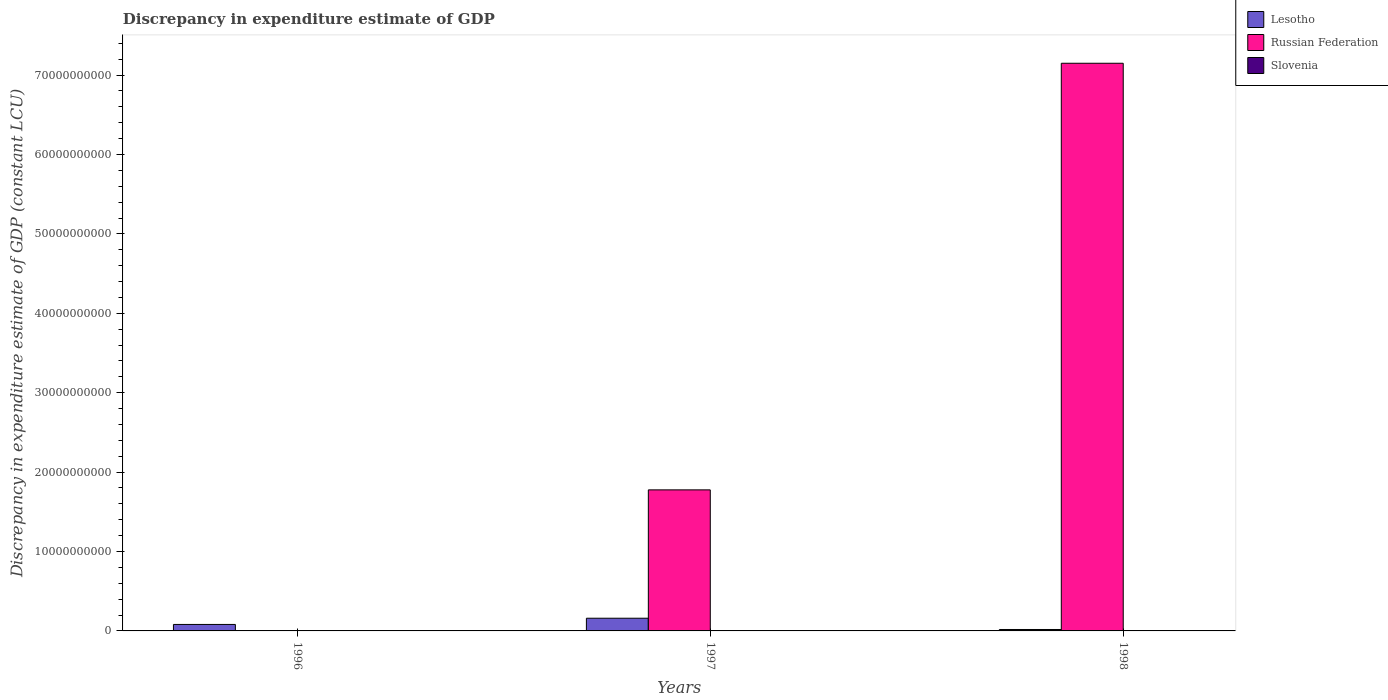How many different coloured bars are there?
Make the answer very short. 2. How many bars are there on the 2nd tick from the right?
Provide a succinct answer. 2. What is the label of the 3rd group of bars from the left?
Offer a terse response. 1998. What is the discrepancy in expenditure estimate of GDP in Lesotho in 1996?
Keep it short and to the point. 8.15e+08. Across all years, what is the maximum discrepancy in expenditure estimate of GDP in Russian Federation?
Keep it short and to the point. 7.15e+1. Across all years, what is the minimum discrepancy in expenditure estimate of GDP in Russian Federation?
Give a very brief answer. 0. What is the total discrepancy in expenditure estimate of GDP in Russian Federation in the graph?
Offer a terse response. 8.93e+1. What is the difference between the discrepancy in expenditure estimate of GDP in Lesotho in 1997 and that in 1998?
Give a very brief answer. 1.42e+09. What is the difference between the discrepancy in expenditure estimate of GDP in Slovenia in 1998 and the discrepancy in expenditure estimate of GDP in Lesotho in 1997?
Ensure brevity in your answer.  -1.60e+09. What is the average discrepancy in expenditure estimate of GDP in Lesotho per year?
Provide a succinct answer. 8.64e+08. In the year 1998, what is the difference between the discrepancy in expenditure estimate of GDP in Russian Federation and discrepancy in expenditure estimate of GDP in Lesotho?
Keep it short and to the point. 7.13e+1. In how many years, is the discrepancy in expenditure estimate of GDP in Russian Federation greater than 34000000000 LCU?
Give a very brief answer. 1. What is the ratio of the discrepancy in expenditure estimate of GDP in Russian Federation in 1997 to that in 1998?
Provide a short and direct response. 0.25. Is the discrepancy in expenditure estimate of GDP in Lesotho in 1996 less than that in 1998?
Your answer should be very brief. No. Is the difference between the discrepancy in expenditure estimate of GDP in Russian Federation in 1997 and 1998 greater than the difference between the discrepancy in expenditure estimate of GDP in Lesotho in 1997 and 1998?
Keep it short and to the point. No. What is the difference between the highest and the second highest discrepancy in expenditure estimate of GDP in Lesotho?
Provide a succinct answer. 7.83e+08. What is the difference between the highest and the lowest discrepancy in expenditure estimate of GDP in Lesotho?
Keep it short and to the point. 1.42e+09. Is it the case that in every year, the sum of the discrepancy in expenditure estimate of GDP in Russian Federation and discrepancy in expenditure estimate of GDP in Lesotho is greater than the discrepancy in expenditure estimate of GDP in Slovenia?
Offer a terse response. Yes. Are all the bars in the graph horizontal?
Your response must be concise. No. What is the difference between two consecutive major ticks on the Y-axis?
Provide a succinct answer. 1.00e+1. Does the graph contain grids?
Your answer should be very brief. No. Where does the legend appear in the graph?
Ensure brevity in your answer.  Top right. What is the title of the graph?
Provide a short and direct response. Discrepancy in expenditure estimate of GDP. What is the label or title of the X-axis?
Your response must be concise. Years. What is the label or title of the Y-axis?
Provide a succinct answer. Discrepancy in expenditure estimate of GDP (constant LCU). What is the Discrepancy in expenditure estimate of GDP (constant LCU) in Lesotho in 1996?
Your answer should be very brief. 8.15e+08. What is the Discrepancy in expenditure estimate of GDP (constant LCU) of Russian Federation in 1996?
Make the answer very short. 0. What is the Discrepancy in expenditure estimate of GDP (constant LCU) of Slovenia in 1996?
Your answer should be very brief. 0. What is the Discrepancy in expenditure estimate of GDP (constant LCU) in Lesotho in 1997?
Provide a short and direct response. 1.60e+09. What is the Discrepancy in expenditure estimate of GDP (constant LCU) of Russian Federation in 1997?
Offer a very short reply. 1.78e+1. What is the Discrepancy in expenditure estimate of GDP (constant LCU) in Slovenia in 1997?
Ensure brevity in your answer.  0. What is the Discrepancy in expenditure estimate of GDP (constant LCU) in Lesotho in 1998?
Keep it short and to the point. 1.79e+08. What is the Discrepancy in expenditure estimate of GDP (constant LCU) in Russian Federation in 1998?
Ensure brevity in your answer.  7.15e+1. What is the Discrepancy in expenditure estimate of GDP (constant LCU) in Slovenia in 1998?
Keep it short and to the point. 0. Across all years, what is the maximum Discrepancy in expenditure estimate of GDP (constant LCU) in Lesotho?
Your answer should be compact. 1.60e+09. Across all years, what is the maximum Discrepancy in expenditure estimate of GDP (constant LCU) of Russian Federation?
Ensure brevity in your answer.  7.15e+1. Across all years, what is the minimum Discrepancy in expenditure estimate of GDP (constant LCU) in Lesotho?
Give a very brief answer. 1.79e+08. What is the total Discrepancy in expenditure estimate of GDP (constant LCU) of Lesotho in the graph?
Offer a very short reply. 2.59e+09. What is the total Discrepancy in expenditure estimate of GDP (constant LCU) in Russian Federation in the graph?
Offer a terse response. 8.93e+1. What is the difference between the Discrepancy in expenditure estimate of GDP (constant LCU) of Lesotho in 1996 and that in 1997?
Ensure brevity in your answer.  -7.83e+08. What is the difference between the Discrepancy in expenditure estimate of GDP (constant LCU) of Lesotho in 1996 and that in 1998?
Make the answer very short. 6.36e+08. What is the difference between the Discrepancy in expenditure estimate of GDP (constant LCU) of Lesotho in 1997 and that in 1998?
Provide a short and direct response. 1.42e+09. What is the difference between the Discrepancy in expenditure estimate of GDP (constant LCU) of Russian Federation in 1997 and that in 1998?
Offer a very short reply. -5.37e+1. What is the difference between the Discrepancy in expenditure estimate of GDP (constant LCU) of Lesotho in 1996 and the Discrepancy in expenditure estimate of GDP (constant LCU) of Russian Federation in 1997?
Provide a short and direct response. -1.69e+1. What is the difference between the Discrepancy in expenditure estimate of GDP (constant LCU) of Lesotho in 1996 and the Discrepancy in expenditure estimate of GDP (constant LCU) of Russian Federation in 1998?
Give a very brief answer. -7.07e+1. What is the difference between the Discrepancy in expenditure estimate of GDP (constant LCU) of Lesotho in 1997 and the Discrepancy in expenditure estimate of GDP (constant LCU) of Russian Federation in 1998?
Provide a succinct answer. -6.99e+1. What is the average Discrepancy in expenditure estimate of GDP (constant LCU) of Lesotho per year?
Offer a terse response. 8.64e+08. What is the average Discrepancy in expenditure estimate of GDP (constant LCU) in Russian Federation per year?
Your answer should be very brief. 2.98e+1. In the year 1997, what is the difference between the Discrepancy in expenditure estimate of GDP (constant LCU) of Lesotho and Discrepancy in expenditure estimate of GDP (constant LCU) of Russian Federation?
Offer a very short reply. -1.62e+1. In the year 1998, what is the difference between the Discrepancy in expenditure estimate of GDP (constant LCU) of Lesotho and Discrepancy in expenditure estimate of GDP (constant LCU) of Russian Federation?
Your answer should be compact. -7.13e+1. What is the ratio of the Discrepancy in expenditure estimate of GDP (constant LCU) in Lesotho in 1996 to that in 1997?
Give a very brief answer. 0.51. What is the ratio of the Discrepancy in expenditure estimate of GDP (constant LCU) in Lesotho in 1996 to that in 1998?
Your response must be concise. 4.55. What is the ratio of the Discrepancy in expenditure estimate of GDP (constant LCU) of Lesotho in 1997 to that in 1998?
Ensure brevity in your answer.  8.92. What is the ratio of the Discrepancy in expenditure estimate of GDP (constant LCU) of Russian Federation in 1997 to that in 1998?
Offer a terse response. 0.25. What is the difference between the highest and the second highest Discrepancy in expenditure estimate of GDP (constant LCU) of Lesotho?
Your response must be concise. 7.83e+08. What is the difference between the highest and the lowest Discrepancy in expenditure estimate of GDP (constant LCU) of Lesotho?
Your answer should be compact. 1.42e+09. What is the difference between the highest and the lowest Discrepancy in expenditure estimate of GDP (constant LCU) in Russian Federation?
Offer a terse response. 7.15e+1. 